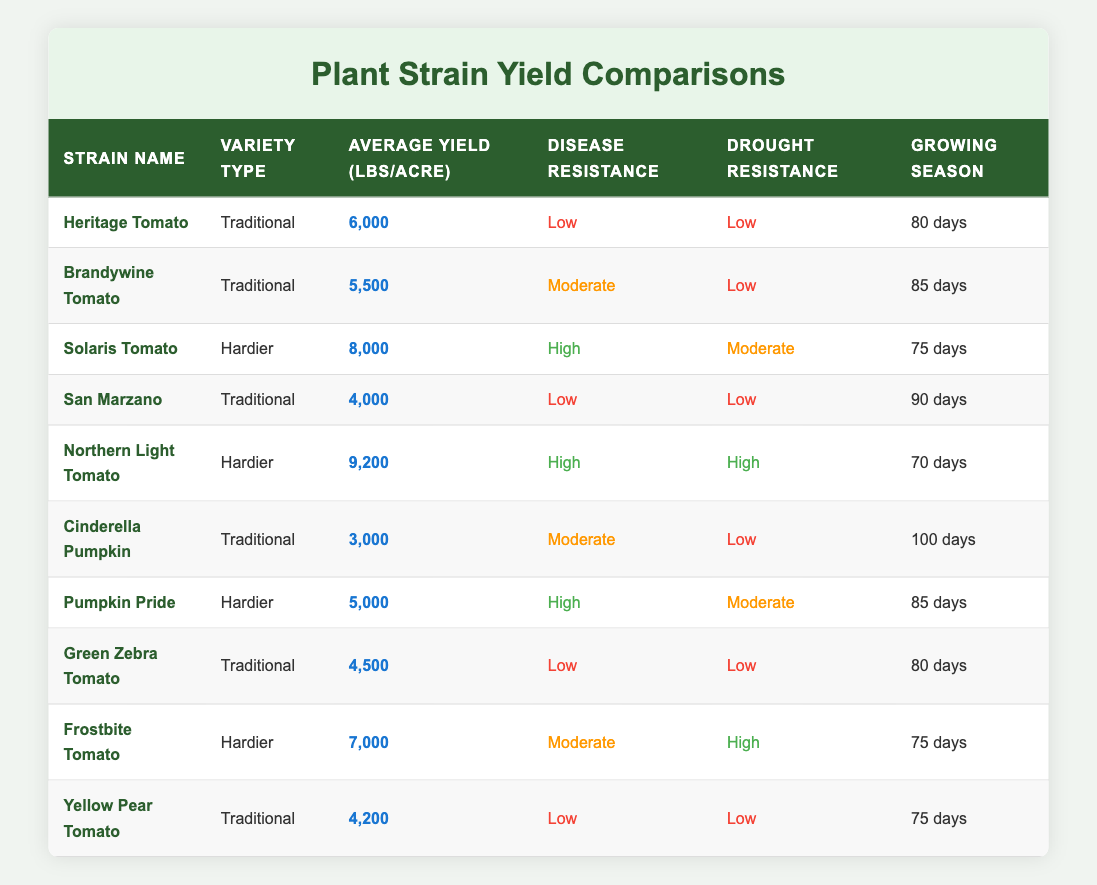What is the average yield per acre for the hardier plant strains? The hardier plant strains are Solaris Tomato (8000 lbs/acre), Northern Light Tomato (9200 lbs/acre), Pumpkin Pride (5000 lbs/acre), and Frostbite Tomato (7000 lbs/acre). Sum these yields (8000 + 9200 + 5000 + 7000 = 29200), and divide by the number of strains (4) to get the average: 29200 / 4 = 7300.
Answer: 7300 Which traditional strain has the highest average yield per acre? The traditional strains listed are Heritage Tomato (6000 lbs/acre), Brandywine Tomato (5500 lbs/acre), San Marzano (4000 lbs/acre), Cinderella Pumpkin (3000 lbs/acre), Green Zebra Tomato (4500 lbs/acre), and Yellow Pear Tomato (4200 lbs/acre). The maximum yield is found by comparing all values, and Heritage Tomato has the highest yield at 6000 lbs/acre.
Answer: Heritage Tomato Is the Northern Light Tomato resistant to both diseases and drought? The Northern Light Tomato has high disease resistance and high drought resistance, as stated in the table. Therefore, it is resistant to both.
Answer: Yes What is the difference in average yield per acre between the hardier and traditional strains? The average yield per acre for hardier strains is 7300 lbs, while for traditional strains (Heritage Tomato 6000, Brandywine Tomato 5500, San Marzano 4000, Cinderella Pumpkin 3000, Green Zebra Tomato 4500, Yellow Pear Tomato 4200) it is 4500 lbs. The difference is calculated as 7300 - 4500 = 2800 lbs.
Answer: 2800 Which plant strain has the longest growing season? Review the growing season lengths: Heritage Tomato (80 days), Brandywine Tomato (85 days), San Marzano (90 days), Cinderella Pumpkin (100 days), Green Zebra Tomato (80 days), Yellow Pear Tomato (75 days), Solaris Tomato (75 days), Northern Light Tomato (70 days), Pumpkin Pride (85 days), and Frostbite Tomato (75 days). The longest growing season is Cinderella Pumpkin at 100 days.
Answer: Cinderella Pumpkin Are there any hardier strains with low disease resistance? Evaluating the hardier strains: Solaris Tomato (high), Northern Light Tomato (high), Pumpkin Pride (high), and Frostbite Tomato (moderate). None of these have low disease resistance, confirming there are no hardier strains with low resistance.
Answer: No What is the yield difference between the highest and lowest yielding traditional strains? The highest yielding traditional strain is Heritage Tomato with 6000 lbs/acre, and the lowest is Cinderella Pumpkin with 3000 lbs/acre. The difference is 6000 - 3000 = 3000 lbs.
Answer: 3000 How many days does the Frostbite Tomato require for its growing season? The table indicates that the Frostbite Tomato has a growing season length of 75 days.
Answer: 75 days What is the yield difference between the Solaris Tomato and the lowest yielding strain overall? The Solaris Tomato yields 8000 lbs/acre, and the lowest yielding strain is Cinderella Pumpkin at 3000 lbs/acre. Thus, the difference is 8000 - 3000 = 5000 lbs.
Answer: 5000 Which type of plant strain has more varieties listed, traditional or hardier? The traditional strains listed are Heritage Tomato, Brandywine Tomato, San Marzano, Cinderella Pumpkin, Green Zebra Tomato, and Yellow Pear Tomato (6 varieties). The hardier strains are Solaris Tomato, Northern Light Tomato, Pumpkin Pride, and Frostbite Tomato (4 varieties). So, traditional strains have more varieties.
Answer: Traditional Which plant strain has both high disease resistance and drought resistance? Checking the strains, Northern Light Tomato has high disease resistance and high drought resistance. So this strain meets both criteria.
Answer: Northern Light Tomato 